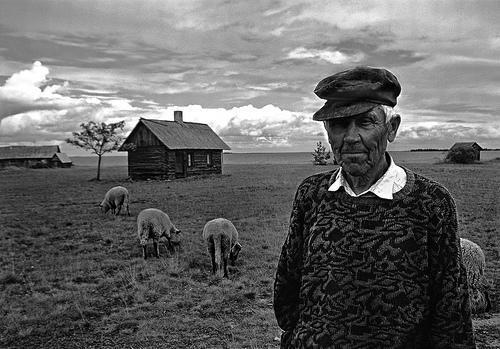How many animals are there?
Give a very brief answer. 4. How many people are there?
Give a very brief answer. 1. 